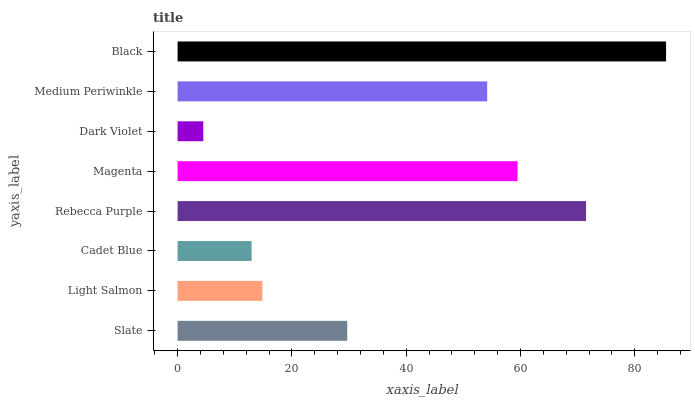Is Dark Violet the minimum?
Answer yes or no. Yes. Is Black the maximum?
Answer yes or no. Yes. Is Light Salmon the minimum?
Answer yes or no. No. Is Light Salmon the maximum?
Answer yes or no. No. Is Slate greater than Light Salmon?
Answer yes or no. Yes. Is Light Salmon less than Slate?
Answer yes or no. Yes. Is Light Salmon greater than Slate?
Answer yes or no. No. Is Slate less than Light Salmon?
Answer yes or no. No. Is Medium Periwinkle the high median?
Answer yes or no. Yes. Is Slate the low median?
Answer yes or no. Yes. Is Rebecca Purple the high median?
Answer yes or no. No. Is Medium Periwinkle the low median?
Answer yes or no. No. 